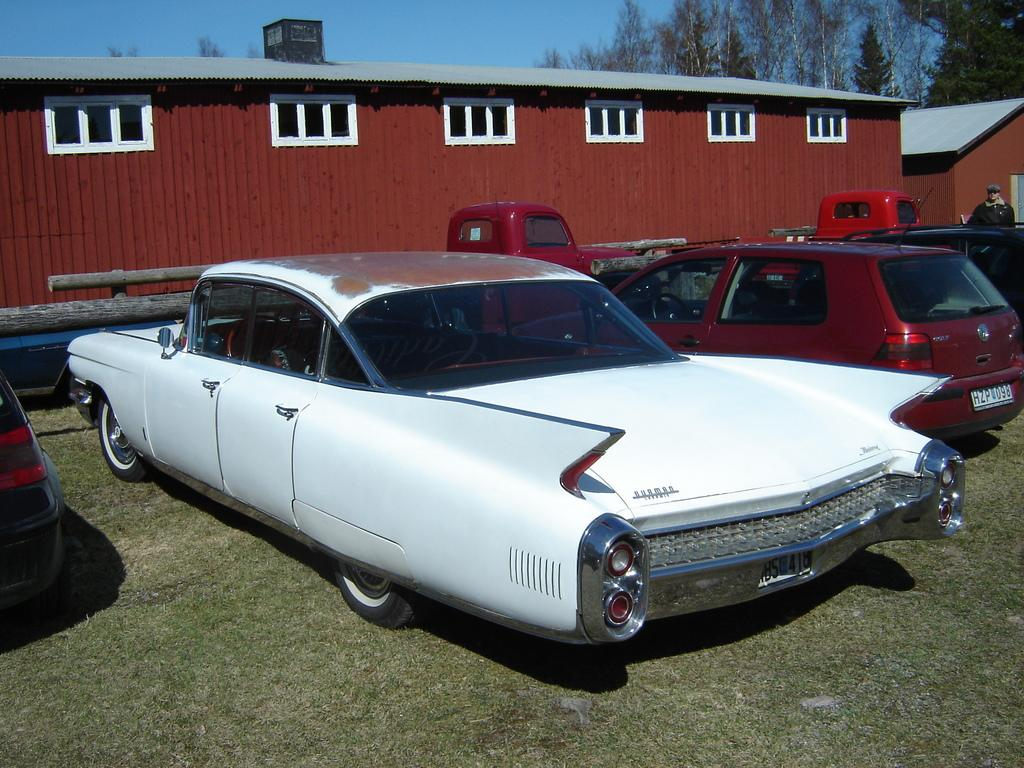What can be seen in front of the building in the image? There are vehicles parked in front of the building in the image. What type of structure is visible in the image? There is a building in the image. What can be seen in the background of the image? There are trees in the background of the image. How would you describe the sky in the image? The sky is clear in the image. Are there any dolls expressing regret in the image? There are no dolls or any indication of regret present in the image. What type of writing can be seen on the building in the image? There is no writing visible on the building in the image. 